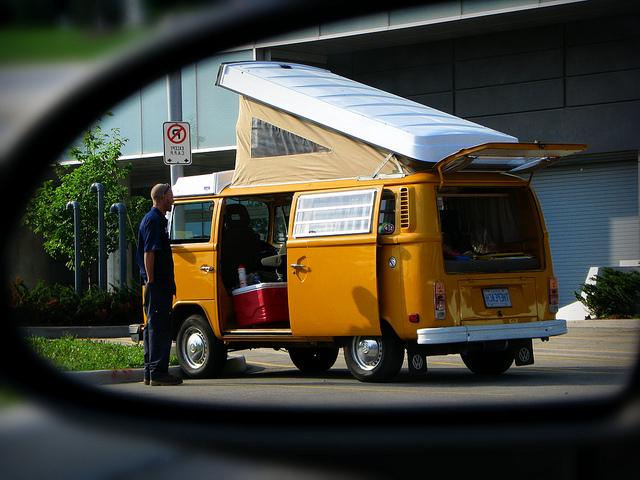How many tires does the vehicle have?
Concise answer only. 4. Is this a caravan?
Keep it brief. No. What color is the van?
Short answer required. Yellow. What color is the vehicle?
Quick response, please. Yellow. How many suitcases are there?
Be succinct. 1. 